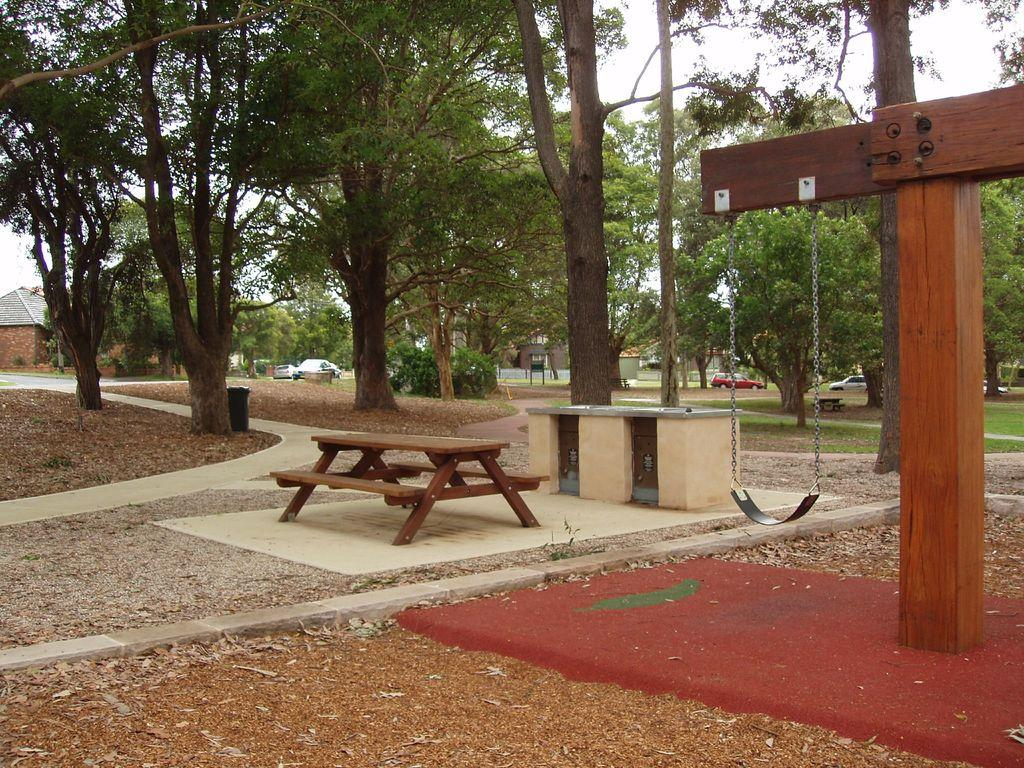What is attached to the wooden surface in the image? There is a swing attached to a wooden surface in the image. What other furniture or objects can be seen in the image? There is a table in the image. What can be seen in the background of the image? Trees, vehicles, houses, and the sky are visible in the background of the image. How many eggs are on the swing in the image? There are no eggs present on the swing or in the image. What type of wheel is attached to the governor in the image? There is no wheel or governor present in the image. 